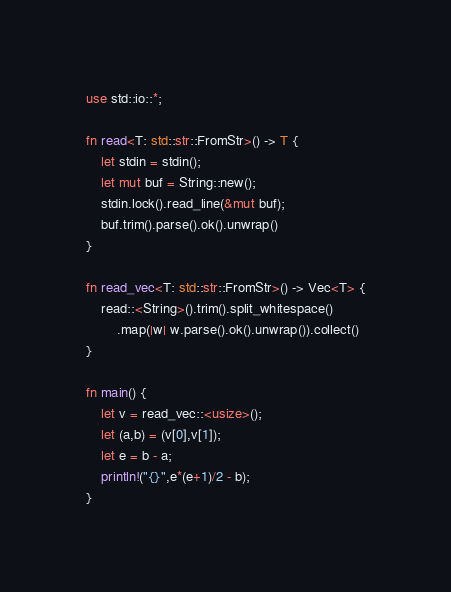Convert code to text. <code><loc_0><loc_0><loc_500><loc_500><_Rust_>use std::io::*;

fn read<T: std::str::FromStr>() -> T {
    let stdin = stdin();
    let mut buf = String::new();
	stdin.lock().read_line(&mut buf);
	buf.trim().parse().ok().unwrap()
}

fn read_vec<T: std::str::FromStr>() -> Vec<T> {
	read::<String>().trim().split_whitespace()
        .map(|w| w.parse().ok().unwrap()).collect()
}

fn main() {
    let v = read_vec::<usize>();
    let (a,b) = (v[0],v[1]);
    let e = b - a;
    println!("{}",e*(e+1)/2 - b);
}
</code> 